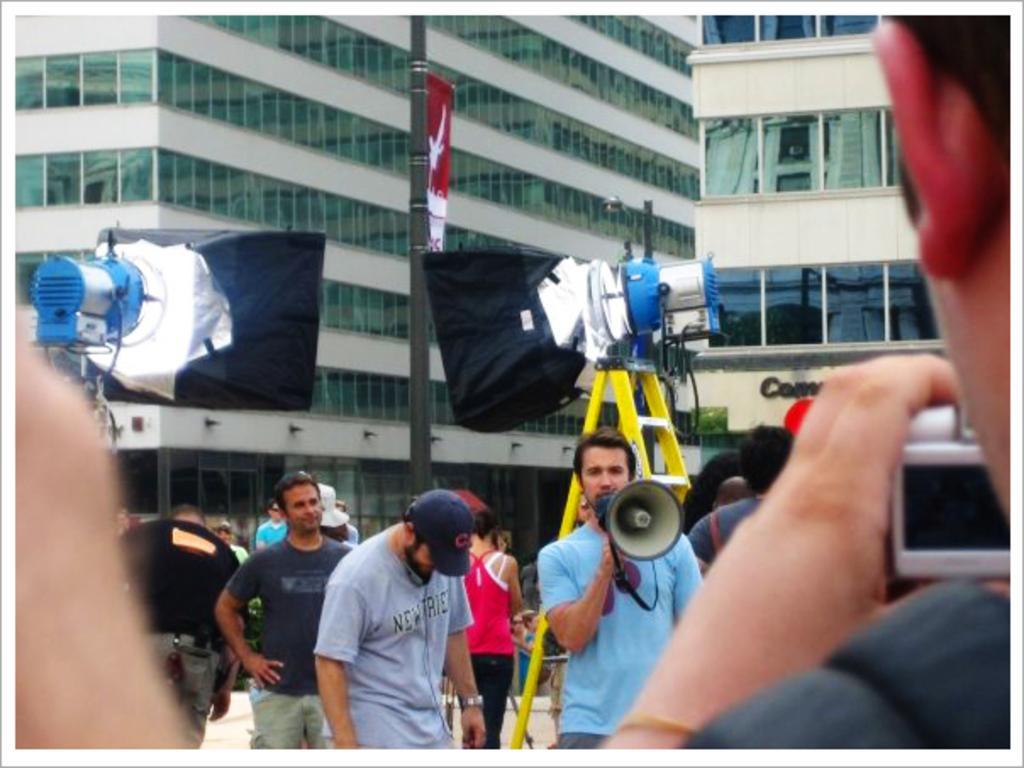Describe this image in one or two sentences. These are buildings. These persons are standing. This person is holding a speaker. These are stands. 